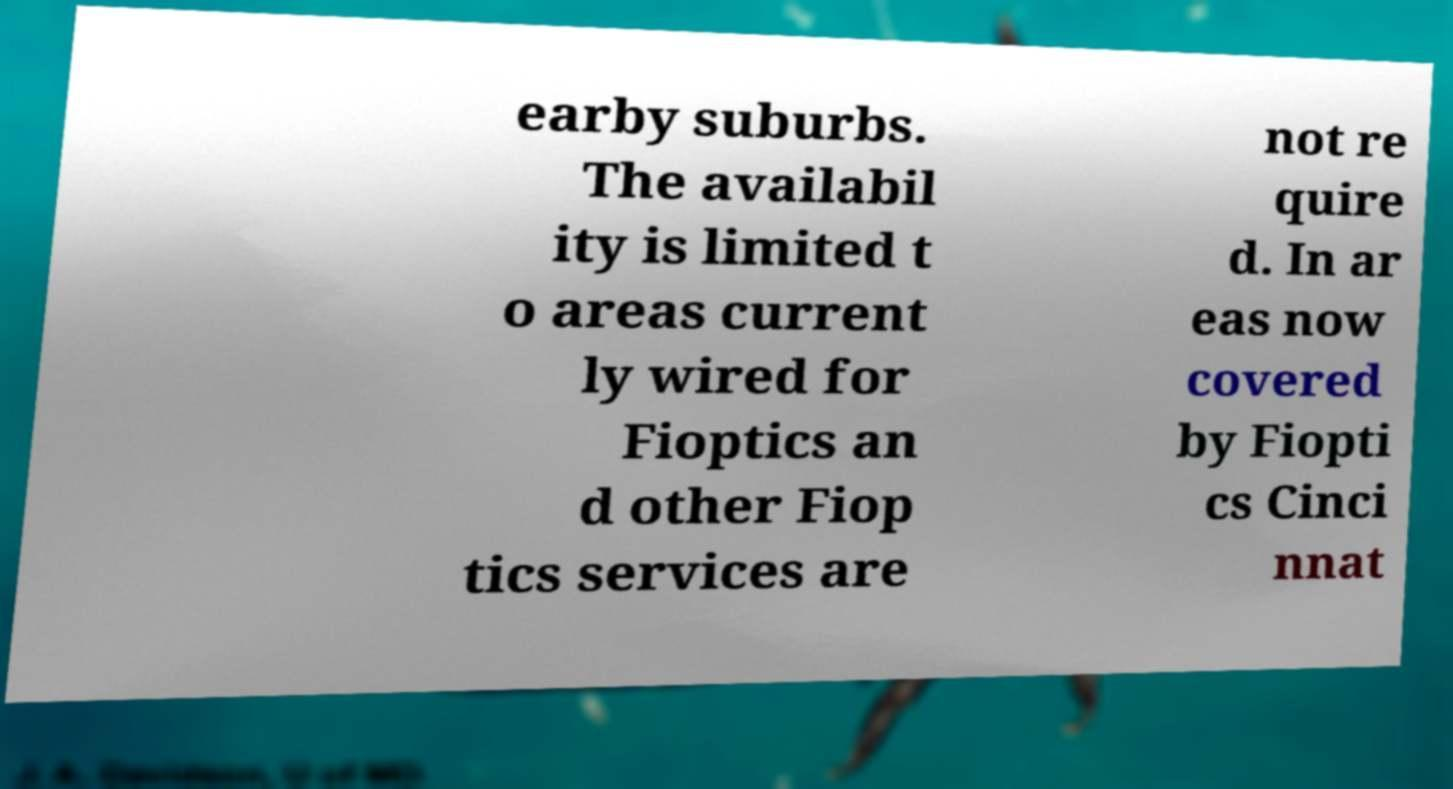Can you read and provide the text displayed in the image?This photo seems to have some interesting text. Can you extract and type it out for me? earby suburbs. The availabil ity is limited t o areas current ly wired for Fioptics an d other Fiop tics services are not re quire d. In ar eas now covered by Fiopti cs Cinci nnat 